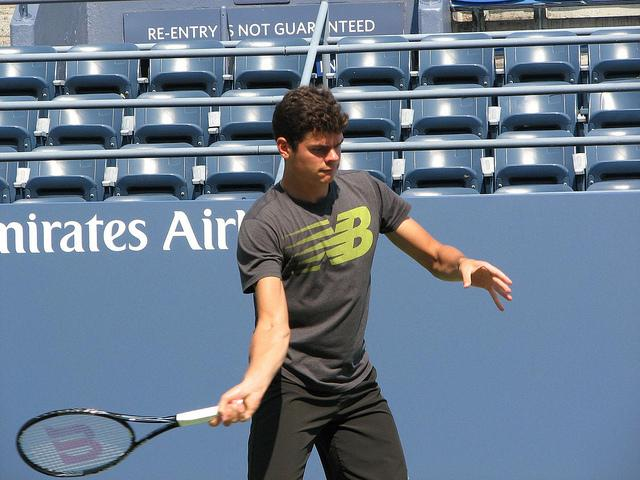What city is the sponsor of the arena located? Please explain your reasoning. dubai. The arena has a sponsorship ad on the wall for the emirates airlines. i used the internet to search where their headquarters are located. 